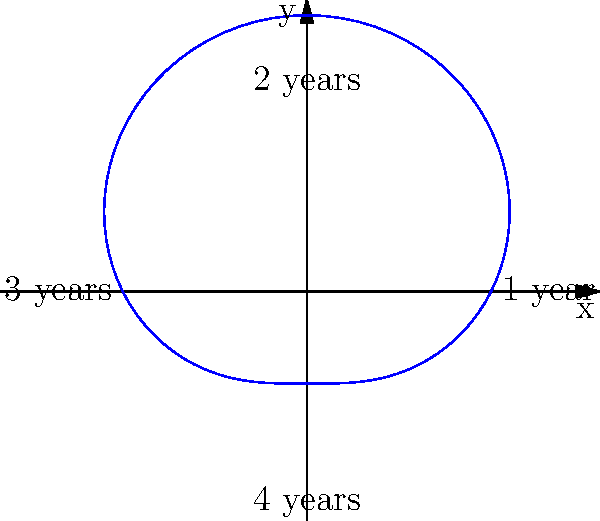As a florist with a love for storytelling, you're documenting the growth pattern of a climbing rose planted by one of the community elders. The polar graph represents the rose's spread over four years. What shape does the growth pattern most closely resemble, and what might this tell us about the rose's story? To analyze the growth pattern of the climbing rose:

1. Observe the overall shape of the graph. It appears to be a circle with slight variations.

2. Notice the four labeled points representing years:
   - 1 year: (2,0)
   - 2 years: (0,2)
   - 3 years: (-2,0)
   - 4 years: (0,-2)

3. The shape resembles a heart or a cardioid, which is represented by the polar equation:
   $r = a(1 + \cos(\theta))$ or $r = a(1 + \sin(\theta))$

4. In this case, the equation is closer to $r = 2 + \sin(\theta)$, where 2 is the average radius.

5. The heart shape suggests:
   - Uneven growth: The rose grows more in some directions than others.
   - Cyclical pattern: The growth follows a repeating pattern over the years.
   - Resilience: Despite variations, the rose maintains a balanced overall shape.

6. Storytelling interpretation:
   - The heart shape could symbolize the elder's love for gardening.
   - The variations might represent challenges faced by the rose or the elder over the years.
   - The overall balanced shape could indicate perseverance and adaptation.
Answer: Heart-shaped (cardioid), symbolizing love, resilience, and cyclical growth in the elder's garden story. 